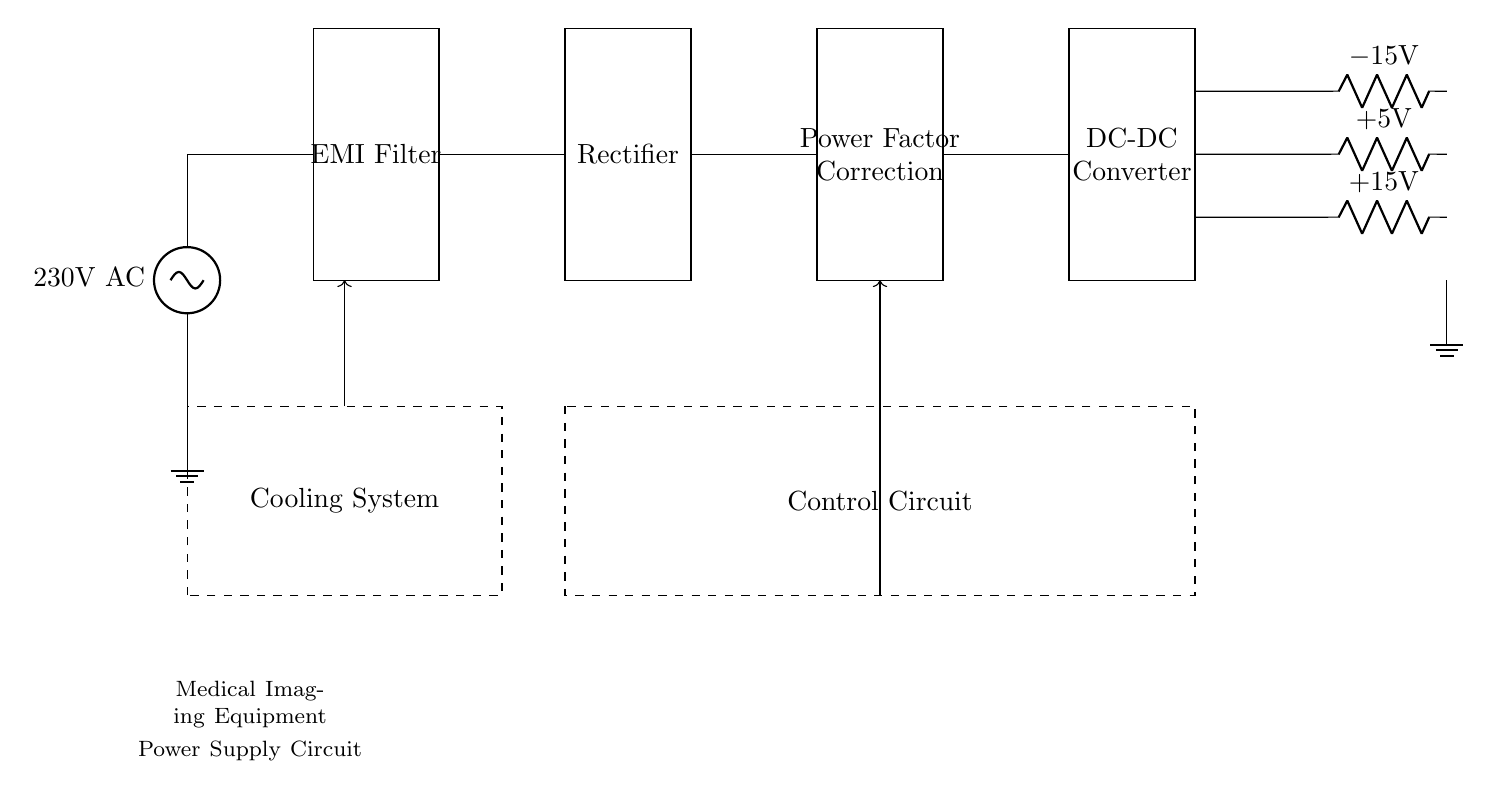What is the input voltage of the circuit? The input voltage to the circuit is labeled as 230V AC, which is shown directly at the entry point of the circuit.
Answer: 230V AC What components are used to convert AC to DC? The components for converting AC to DC in this circuit are the Rectifier, situated after the EMI Filter and before the Power Factor Correction circuit.
Answer: Rectifier What are the output voltage levels in this circuit? The output voltage levels indicated in the circuit are +15V, +5V, and -15V, which can be found along the output lines at the end.
Answer: +15V, +5V, -15V How does the AC supply interact with the EMI filter? The AC supply connects directly to the EMI filter as an entry point, where it undergoes initial conditioning to reduce electromagnetic interference before proceeding further in the circuit.
Answer: It reduces electromagnetic interference What is the purpose of the Control Circuit in this setup? The Control Circuit is responsible for managing the overall functioning and safety of the power supply circuit, ensuring proper operation by controlling the power flow and protecting against faults.
Answer: Management of power flow and safety Which component is responsible for power factor correction? The component responsible for power factor correction in this circuit is labeled as Power Factor Correction, located directly after the Rectifier.
Answer: Power Factor Correction What does the Cooling System do in this power supply circuit? The Cooling System is designated to manage heat dissipation and maintain optimal operating temperatures for components within the power supply circuit, indicated by the dashed box surrounding it.
Answer: Manages heat dissipation 